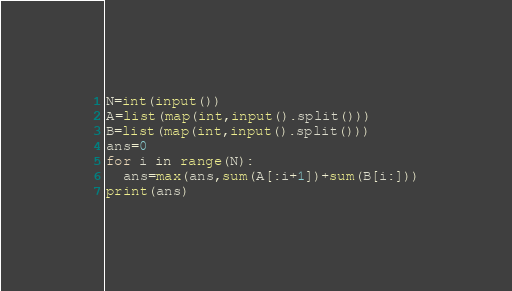Convert code to text. <code><loc_0><loc_0><loc_500><loc_500><_Python_>N=int(input())
A=list(map(int,input().split()))
B=list(map(int,input().split()))
ans=0
for i in range(N):
  ans=max(ans,sum(A[:i+1])+sum(B[i:]))
print(ans)</code> 